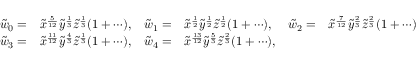Convert formula to latex. <formula><loc_0><loc_0><loc_500><loc_500>\begin{array} { r l r l r l r l } & { \tilde { w } _ { 0 } = } & { \tilde { x } ^ { \frac { 5 } { 1 2 } } \tilde { y } ^ { \frac { 1 } { 3 } } \tilde { z } ^ { \frac { 1 } { 3 } } ( 1 + \cdots ) , } & { \tilde { w } _ { 1 } = } & { \tilde { x } ^ { \frac { 1 } { 2 } } \tilde { y } ^ { \frac { 1 } { 2 } } \tilde { z } ^ { \frac { 1 } { 2 } } ( 1 + \cdots ) , } & { \tilde { w } _ { 2 } = } & { \tilde { x } ^ { \frac { 7 } { 1 2 } } \tilde { y } ^ { \frac { 2 } { 3 } } \tilde { z } ^ { \frac { 2 } { 3 } } ( 1 + \cdots ) } \\ & { \tilde { w } _ { 3 } = } & { \tilde { x } ^ { \frac { 1 1 } { 1 2 } } \tilde { y } ^ { \frac { 4 } { 3 } } \tilde { z } ^ { \frac { 1 } { 3 } } ( 1 + \cdots ) , } & { \tilde { w } _ { 4 } = } & { \tilde { x } ^ { \frac { 1 3 } { 1 2 } } \tilde { y } ^ { \frac { 5 } { 3 } } \tilde { z } ^ { \frac { 2 } { 3 } } ( 1 + \cdots ) , } \end{array}</formula> 